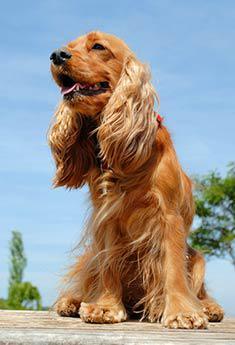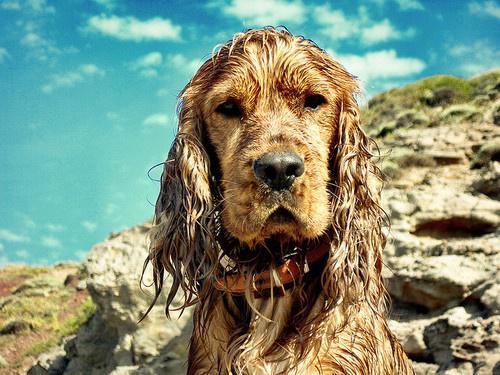The first image is the image on the left, the second image is the image on the right. Examine the images to the left and right. Is the description "An image shows a gold-colored puppy with at least one paw draped over something." accurate? Answer yes or no. No. The first image is the image on the left, the second image is the image on the right. Given the left and right images, does the statement "One of the images contains a dog only showing its two front legs." hold true? Answer yes or no. No. 